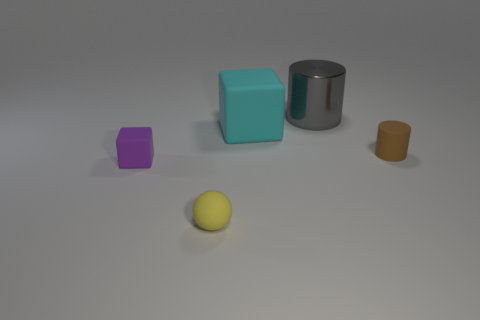Add 2 matte blocks. How many objects exist? 7 Subtract all brown cylinders. How many cylinders are left? 1 Subtract all balls. How many objects are left? 4 Add 3 large cyan rubber cubes. How many large cyan rubber cubes are left? 4 Add 5 gray cylinders. How many gray cylinders exist? 6 Subtract 0 gray spheres. How many objects are left? 5 Subtract 1 balls. How many balls are left? 0 Subtract all blue balls. Subtract all green cubes. How many balls are left? 1 Subtract all red cylinders. How many gray balls are left? 0 Subtract all tiny yellow things. Subtract all large red rubber cylinders. How many objects are left? 4 